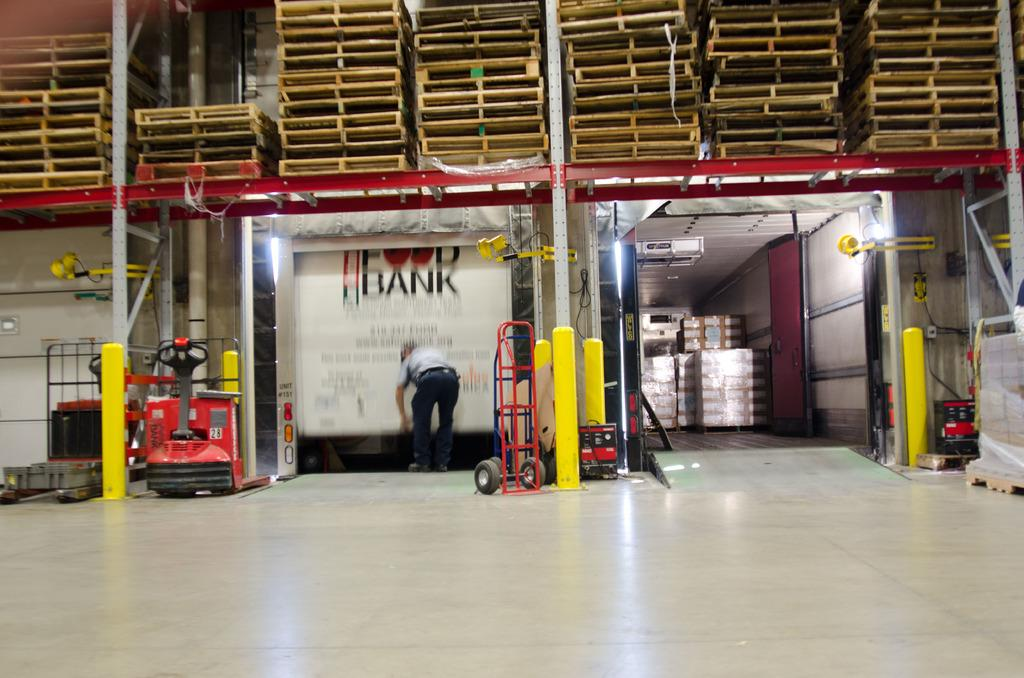What is the main subject of the image? There is a man standing in the image. Where is the man standing? The man is standing on the floor. What can be seen in the background of the image? There is a wall, machines, poles, and other objects in the background of the image. What else is visible in the image besides the man? There are boxes in the image. What type of thumb is the man using to perform magic in the image? There is no thumb or magic present in the image; it features a man standing on the floor with boxes and a background containing a wall, machines, poles, and other objects. What flavor of eggnog is the man holding in the image? There is no eggnog present in the image; it features a man standing on the floor with boxes and a background containing a wall, machines, poles, and other objects. 